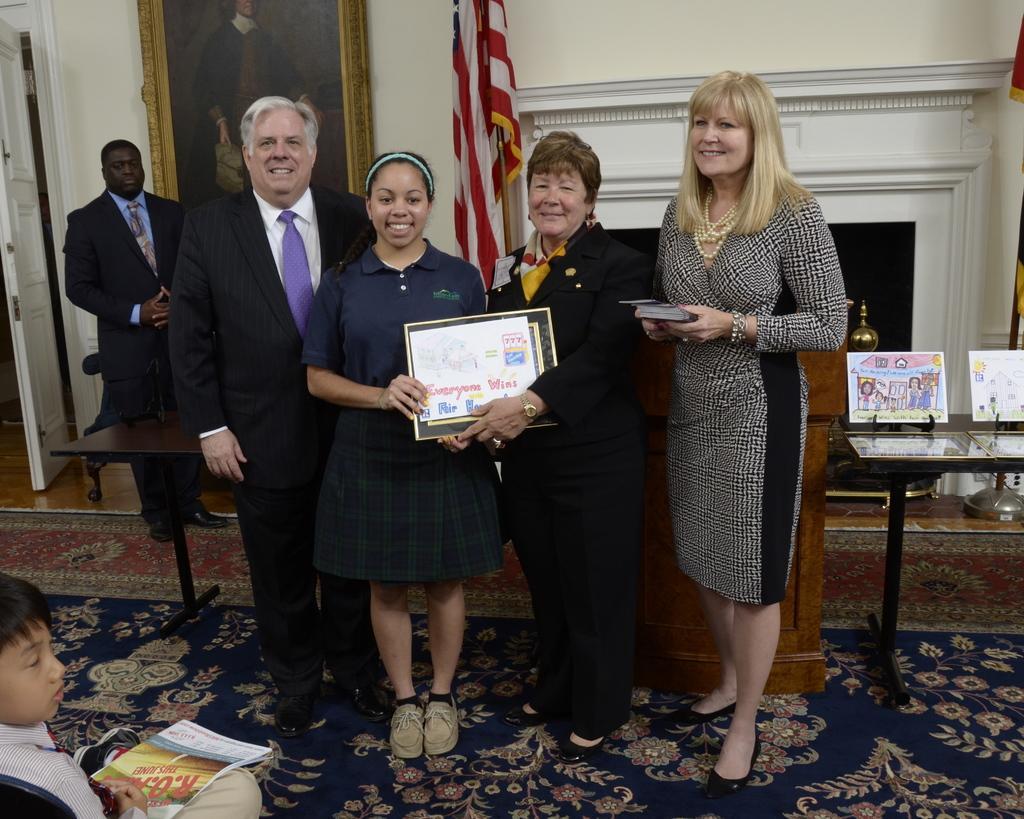Please provide a concise description of this image. There are people those who are standing in the center of the image, they are holding some papers in their hands and there is a boy at the bottom side of the image, there is a book on his laps, there is another man in the background area, there is a door on the left side of the image and there is a portrait, flag, and a table in the background area, there are some papers on the table and a desk on the right side of the image. 